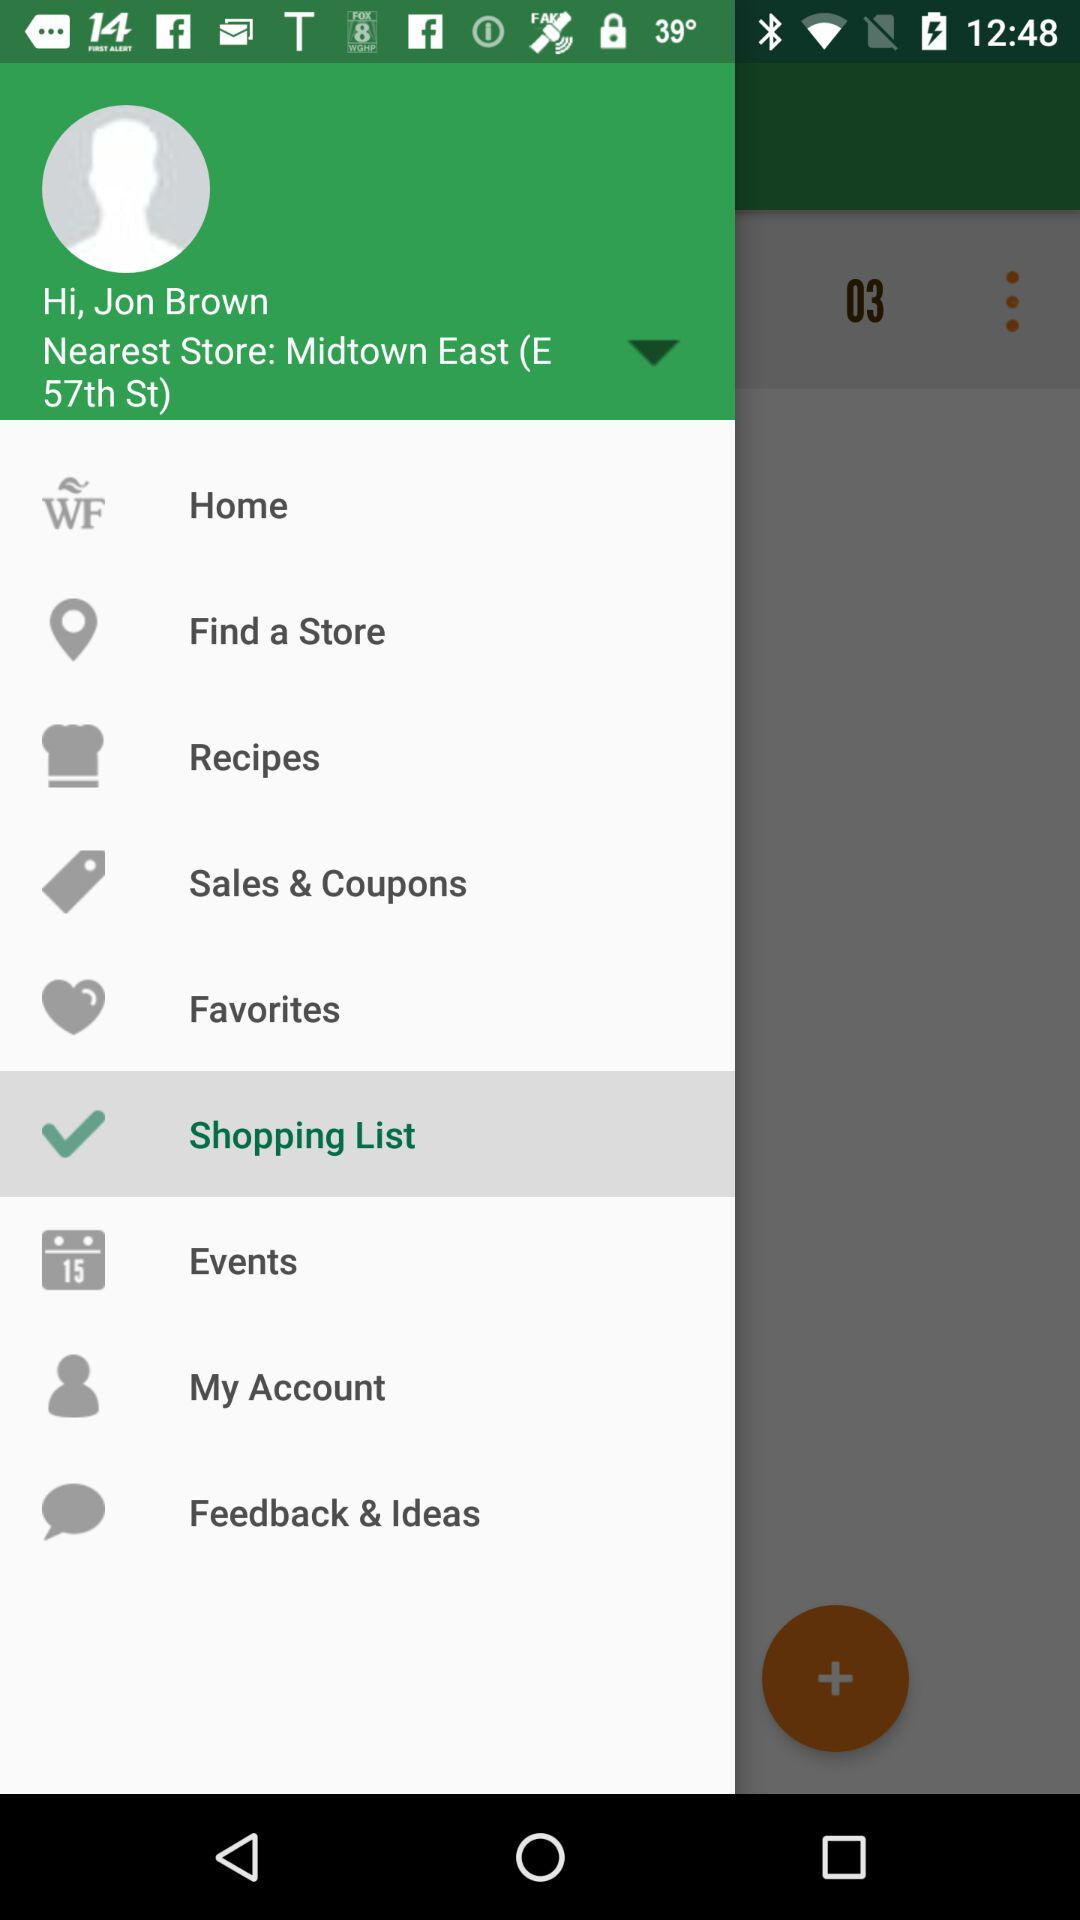What is the location of nearest store? The location of the nearest store is Midtown East (E 57th St). 